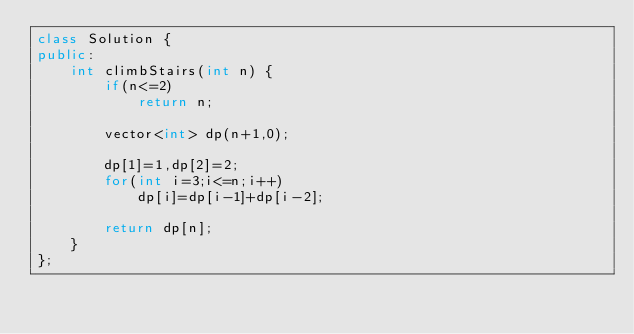Convert code to text. <code><loc_0><loc_0><loc_500><loc_500><_C++_>class Solution {
public:
    int climbStairs(int n) {
        if(n<=2)
            return n;

        vector<int> dp(n+1,0);

        dp[1]=1,dp[2]=2;
        for(int i=3;i<=n;i++)
            dp[i]=dp[i-1]+dp[i-2];

        return dp[n];
    }
};
</code> 